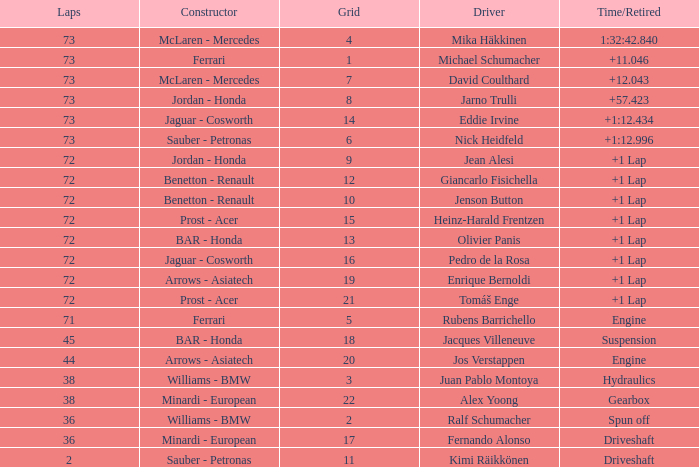Who is the constructor when the laps is more than 72 and the driver is eddie irvine? Jaguar - Cosworth. Would you mind parsing the complete table? {'header': ['Laps', 'Constructor', 'Grid', 'Driver', 'Time/Retired'], 'rows': [['73', 'McLaren - Mercedes', '4', 'Mika Häkkinen', '1:32:42.840'], ['73', 'Ferrari', '1', 'Michael Schumacher', '+11.046'], ['73', 'McLaren - Mercedes', '7', 'David Coulthard', '+12.043'], ['73', 'Jordan - Honda', '8', 'Jarno Trulli', '+57.423'], ['73', 'Jaguar - Cosworth', '14', 'Eddie Irvine', '+1:12.434'], ['73', 'Sauber - Petronas', '6', 'Nick Heidfeld', '+1:12.996'], ['72', 'Jordan - Honda', '9', 'Jean Alesi', '+1 Lap'], ['72', 'Benetton - Renault', '12', 'Giancarlo Fisichella', '+1 Lap'], ['72', 'Benetton - Renault', '10', 'Jenson Button', '+1 Lap'], ['72', 'Prost - Acer', '15', 'Heinz-Harald Frentzen', '+1 Lap'], ['72', 'BAR - Honda', '13', 'Olivier Panis', '+1 Lap'], ['72', 'Jaguar - Cosworth', '16', 'Pedro de la Rosa', '+1 Lap'], ['72', 'Arrows - Asiatech', '19', 'Enrique Bernoldi', '+1 Lap'], ['72', 'Prost - Acer', '21', 'Tomáš Enge', '+1 Lap'], ['71', 'Ferrari', '5', 'Rubens Barrichello', 'Engine'], ['45', 'BAR - Honda', '18', 'Jacques Villeneuve', 'Suspension'], ['44', 'Arrows - Asiatech', '20', 'Jos Verstappen', 'Engine'], ['38', 'Williams - BMW', '3', 'Juan Pablo Montoya', 'Hydraulics'], ['38', 'Minardi - European', '22', 'Alex Yoong', 'Gearbox'], ['36', 'Williams - BMW', '2', 'Ralf Schumacher', 'Spun off'], ['36', 'Minardi - European', '17', 'Fernando Alonso', 'Driveshaft'], ['2', 'Sauber - Petronas', '11', 'Kimi Räikkönen', 'Driveshaft']]} 